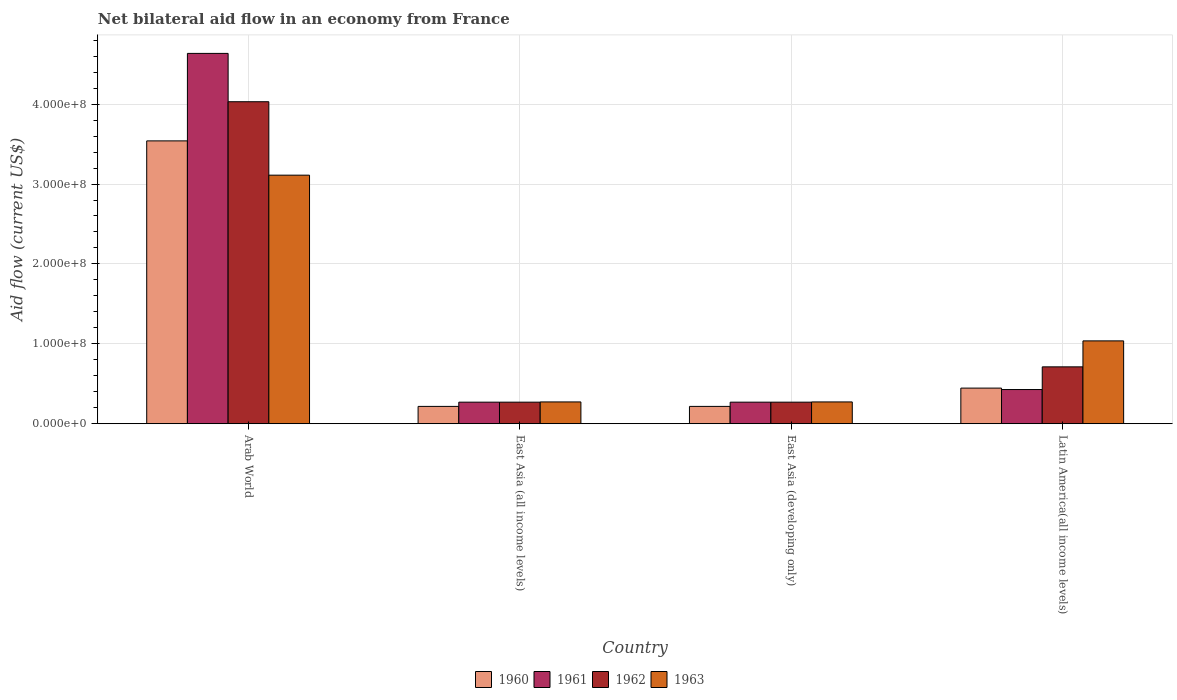How many different coloured bars are there?
Your response must be concise. 4. Are the number of bars per tick equal to the number of legend labels?
Ensure brevity in your answer.  Yes. How many bars are there on the 4th tick from the right?
Give a very brief answer. 4. What is the label of the 4th group of bars from the left?
Ensure brevity in your answer.  Latin America(all income levels). In how many cases, is the number of bars for a given country not equal to the number of legend labels?
Your response must be concise. 0. What is the net bilateral aid flow in 1962 in Latin America(all income levels)?
Your response must be concise. 7.12e+07. Across all countries, what is the maximum net bilateral aid flow in 1962?
Keep it short and to the point. 4.03e+08. Across all countries, what is the minimum net bilateral aid flow in 1963?
Keep it short and to the point. 2.73e+07. In which country was the net bilateral aid flow in 1961 maximum?
Give a very brief answer. Arab World. In which country was the net bilateral aid flow in 1961 minimum?
Give a very brief answer. East Asia (all income levels). What is the total net bilateral aid flow in 1963 in the graph?
Your response must be concise. 4.69e+08. What is the difference between the net bilateral aid flow in 1963 in Arab World and that in East Asia (all income levels)?
Your answer should be compact. 2.84e+08. What is the average net bilateral aid flow in 1961 per country?
Keep it short and to the point. 1.40e+08. What is the difference between the net bilateral aid flow of/in 1961 and net bilateral aid flow of/in 1960 in Latin America(all income levels)?
Make the answer very short. -1.80e+06. In how many countries, is the net bilateral aid flow in 1961 greater than 260000000 US$?
Offer a very short reply. 1. What is the ratio of the net bilateral aid flow in 1963 in East Asia (all income levels) to that in Latin America(all income levels)?
Your answer should be very brief. 0.26. Is the net bilateral aid flow in 1960 in Arab World less than that in East Asia (developing only)?
Keep it short and to the point. No. Is the difference between the net bilateral aid flow in 1961 in Arab World and East Asia (all income levels) greater than the difference between the net bilateral aid flow in 1960 in Arab World and East Asia (all income levels)?
Your answer should be compact. Yes. What is the difference between the highest and the second highest net bilateral aid flow in 1961?
Your answer should be very brief. 4.21e+08. What is the difference between the highest and the lowest net bilateral aid flow in 1963?
Give a very brief answer. 2.84e+08. What does the 4th bar from the left in East Asia (developing only) represents?
Offer a terse response. 1963. Is it the case that in every country, the sum of the net bilateral aid flow in 1962 and net bilateral aid flow in 1961 is greater than the net bilateral aid flow in 1963?
Offer a terse response. Yes. Are all the bars in the graph horizontal?
Give a very brief answer. No. What is the difference between two consecutive major ticks on the Y-axis?
Offer a terse response. 1.00e+08. Does the graph contain grids?
Your response must be concise. Yes. How are the legend labels stacked?
Keep it short and to the point. Horizontal. What is the title of the graph?
Your answer should be compact. Net bilateral aid flow in an economy from France. Does "2012" appear as one of the legend labels in the graph?
Provide a succinct answer. No. What is the label or title of the X-axis?
Ensure brevity in your answer.  Country. What is the Aid flow (current US$) in 1960 in Arab World?
Offer a very short reply. 3.54e+08. What is the Aid flow (current US$) of 1961 in Arab World?
Give a very brief answer. 4.64e+08. What is the Aid flow (current US$) in 1962 in Arab World?
Provide a succinct answer. 4.03e+08. What is the Aid flow (current US$) in 1963 in Arab World?
Give a very brief answer. 3.11e+08. What is the Aid flow (current US$) of 1960 in East Asia (all income levels)?
Offer a terse response. 2.17e+07. What is the Aid flow (current US$) in 1961 in East Asia (all income levels)?
Keep it short and to the point. 2.70e+07. What is the Aid flow (current US$) in 1962 in East Asia (all income levels)?
Provide a short and direct response. 2.70e+07. What is the Aid flow (current US$) in 1963 in East Asia (all income levels)?
Your answer should be very brief. 2.73e+07. What is the Aid flow (current US$) in 1960 in East Asia (developing only)?
Provide a succinct answer. 2.17e+07. What is the Aid flow (current US$) in 1961 in East Asia (developing only)?
Your response must be concise. 2.70e+07. What is the Aid flow (current US$) of 1962 in East Asia (developing only)?
Give a very brief answer. 2.70e+07. What is the Aid flow (current US$) of 1963 in East Asia (developing only)?
Make the answer very short. 2.73e+07. What is the Aid flow (current US$) in 1960 in Latin America(all income levels)?
Offer a very short reply. 4.46e+07. What is the Aid flow (current US$) of 1961 in Latin America(all income levels)?
Offer a terse response. 4.28e+07. What is the Aid flow (current US$) of 1962 in Latin America(all income levels)?
Ensure brevity in your answer.  7.12e+07. What is the Aid flow (current US$) of 1963 in Latin America(all income levels)?
Keep it short and to the point. 1.04e+08. Across all countries, what is the maximum Aid flow (current US$) of 1960?
Keep it short and to the point. 3.54e+08. Across all countries, what is the maximum Aid flow (current US$) of 1961?
Offer a terse response. 4.64e+08. Across all countries, what is the maximum Aid flow (current US$) in 1962?
Make the answer very short. 4.03e+08. Across all countries, what is the maximum Aid flow (current US$) of 1963?
Provide a short and direct response. 3.11e+08. Across all countries, what is the minimum Aid flow (current US$) in 1960?
Offer a terse response. 2.17e+07. Across all countries, what is the minimum Aid flow (current US$) of 1961?
Keep it short and to the point. 2.70e+07. Across all countries, what is the minimum Aid flow (current US$) of 1962?
Your answer should be very brief. 2.70e+07. Across all countries, what is the minimum Aid flow (current US$) of 1963?
Keep it short and to the point. 2.73e+07. What is the total Aid flow (current US$) in 1960 in the graph?
Provide a short and direct response. 4.42e+08. What is the total Aid flow (current US$) in 1961 in the graph?
Your response must be concise. 5.60e+08. What is the total Aid flow (current US$) in 1962 in the graph?
Your answer should be very brief. 5.28e+08. What is the total Aid flow (current US$) in 1963 in the graph?
Ensure brevity in your answer.  4.69e+08. What is the difference between the Aid flow (current US$) of 1960 in Arab World and that in East Asia (all income levels)?
Your answer should be compact. 3.32e+08. What is the difference between the Aid flow (current US$) in 1961 in Arab World and that in East Asia (all income levels)?
Keep it short and to the point. 4.36e+08. What is the difference between the Aid flow (current US$) in 1962 in Arab World and that in East Asia (all income levels)?
Offer a terse response. 3.76e+08. What is the difference between the Aid flow (current US$) of 1963 in Arab World and that in East Asia (all income levels)?
Make the answer very short. 2.84e+08. What is the difference between the Aid flow (current US$) in 1960 in Arab World and that in East Asia (developing only)?
Make the answer very short. 3.32e+08. What is the difference between the Aid flow (current US$) in 1961 in Arab World and that in East Asia (developing only)?
Your answer should be compact. 4.36e+08. What is the difference between the Aid flow (current US$) of 1962 in Arab World and that in East Asia (developing only)?
Offer a very short reply. 3.76e+08. What is the difference between the Aid flow (current US$) of 1963 in Arab World and that in East Asia (developing only)?
Offer a very short reply. 2.84e+08. What is the difference between the Aid flow (current US$) in 1960 in Arab World and that in Latin America(all income levels)?
Give a very brief answer. 3.09e+08. What is the difference between the Aid flow (current US$) of 1961 in Arab World and that in Latin America(all income levels)?
Give a very brief answer. 4.21e+08. What is the difference between the Aid flow (current US$) in 1962 in Arab World and that in Latin America(all income levels)?
Offer a very short reply. 3.32e+08. What is the difference between the Aid flow (current US$) in 1963 in Arab World and that in Latin America(all income levels)?
Your response must be concise. 2.07e+08. What is the difference between the Aid flow (current US$) of 1961 in East Asia (all income levels) and that in East Asia (developing only)?
Your answer should be compact. 0. What is the difference between the Aid flow (current US$) in 1963 in East Asia (all income levels) and that in East Asia (developing only)?
Provide a succinct answer. 0. What is the difference between the Aid flow (current US$) of 1960 in East Asia (all income levels) and that in Latin America(all income levels)?
Keep it short and to the point. -2.29e+07. What is the difference between the Aid flow (current US$) in 1961 in East Asia (all income levels) and that in Latin America(all income levels)?
Make the answer very short. -1.58e+07. What is the difference between the Aid flow (current US$) in 1962 in East Asia (all income levels) and that in Latin America(all income levels)?
Give a very brief answer. -4.42e+07. What is the difference between the Aid flow (current US$) in 1963 in East Asia (all income levels) and that in Latin America(all income levels)?
Make the answer very short. -7.64e+07. What is the difference between the Aid flow (current US$) in 1960 in East Asia (developing only) and that in Latin America(all income levels)?
Provide a short and direct response. -2.29e+07. What is the difference between the Aid flow (current US$) in 1961 in East Asia (developing only) and that in Latin America(all income levels)?
Provide a succinct answer. -1.58e+07. What is the difference between the Aid flow (current US$) of 1962 in East Asia (developing only) and that in Latin America(all income levels)?
Your answer should be very brief. -4.42e+07. What is the difference between the Aid flow (current US$) in 1963 in East Asia (developing only) and that in Latin America(all income levels)?
Provide a short and direct response. -7.64e+07. What is the difference between the Aid flow (current US$) of 1960 in Arab World and the Aid flow (current US$) of 1961 in East Asia (all income levels)?
Provide a succinct answer. 3.27e+08. What is the difference between the Aid flow (current US$) in 1960 in Arab World and the Aid flow (current US$) in 1962 in East Asia (all income levels)?
Make the answer very short. 3.27e+08. What is the difference between the Aid flow (current US$) in 1960 in Arab World and the Aid flow (current US$) in 1963 in East Asia (all income levels)?
Ensure brevity in your answer.  3.27e+08. What is the difference between the Aid flow (current US$) of 1961 in Arab World and the Aid flow (current US$) of 1962 in East Asia (all income levels)?
Give a very brief answer. 4.36e+08. What is the difference between the Aid flow (current US$) in 1961 in Arab World and the Aid flow (current US$) in 1963 in East Asia (all income levels)?
Your answer should be compact. 4.36e+08. What is the difference between the Aid flow (current US$) in 1962 in Arab World and the Aid flow (current US$) in 1963 in East Asia (all income levels)?
Your response must be concise. 3.76e+08. What is the difference between the Aid flow (current US$) of 1960 in Arab World and the Aid flow (current US$) of 1961 in East Asia (developing only)?
Ensure brevity in your answer.  3.27e+08. What is the difference between the Aid flow (current US$) of 1960 in Arab World and the Aid flow (current US$) of 1962 in East Asia (developing only)?
Your answer should be compact. 3.27e+08. What is the difference between the Aid flow (current US$) in 1960 in Arab World and the Aid flow (current US$) in 1963 in East Asia (developing only)?
Your answer should be very brief. 3.27e+08. What is the difference between the Aid flow (current US$) in 1961 in Arab World and the Aid flow (current US$) in 1962 in East Asia (developing only)?
Give a very brief answer. 4.36e+08. What is the difference between the Aid flow (current US$) of 1961 in Arab World and the Aid flow (current US$) of 1963 in East Asia (developing only)?
Provide a succinct answer. 4.36e+08. What is the difference between the Aid flow (current US$) of 1962 in Arab World and the Aid flow (current US$) of 1963 in East Asia (developing only)?
Your answer should be very brief. 3.76e+08. What is the difference between the Aid flow (current US$) in 1960 in Arab World and the Aid flow (current US$) in 1961 in Latin America(all income levels)?
Your answer should be compact. 3.11e+08. What is the difference between the Aid flow (current US$) in 1960 in Arab World and the Aid flow (current US$) in 1962 in Latin America(all income levels)?
Offer a very short reply. 2.83e+08. What is the difference between the Aid flow (current US$) in 1960 in Arab World and the Aid flow (current US$) in 1963 in Latin America(all income levels)?
Your response must be concise. 2.50e+08. What is the difference between the Aid flow (current US$) in 1961 in Arab World and the Aid flow (current US$) in 1962 in Latin America(all income levels)?
Your answer should be compact. 3.92e+08. What is the difference between the Aid flow (current US$) of 1961 in Arab World and the Aid flow (current US$) of 1963 in Latin America(all income levels)?
Keep it short and to the point. 3.60e+08. What is the difference between the Aid flow (current US$) in 1962 in Arab World and the Aid flow (current US$) in 1963 in Latin America(all income levels)?
Your response must be concise. 2.99e+08. What is the difference between the Aid flow (current US$) of 1960 in East Asia (all income levels) and the Aid flow (current US$) of 1961 in East Asia (developing only)?
Give a very brief answer. -5.30e+06. What is the difference between the Aid flow (current US$) of 1960 in East Asia (all income levels) and the Aid flow (current US$) of 1962 in East Asia (developing only)?
Ensure brevity in your answer.  -5.30e+06. What is the difference between the Aid flow (current US$) in 1960 in East Asia (all income levels) and the Aid flow (current US$) in 1963 in East Asia (developing only)?
Make the answer very short. -5.60e+06. What is the difference between the Aid flow (current US$) in 1960 in East Asia (all income levels) and the Aid flow (current US$) in 1961 in Latin America(all income levels)?
Ensure brevity in your answer.  -2.11e+07. What is the difference between the Aid flow (current US$) in 1960 in East Asia (all income levels) and the Aid flow (current US$) in 1962 in Latin America(all income levels)?
Give a very brief answer. -4.95e+07. What is the difference between the Aid flow (current US$) of 1960 in East Asia (all income levels) and the Aid flow (current US$) of 1963 in Latin America(all income levels)?
Keep it short and to the point. -8.20e+07. What is the difference between the Aid flow (current US$) in 1961 in East Asia (all income levels) and the Aid flow (current US$) in 1962 in Latin America(all income levels)?
Make the answer very short. -4.42e+07. What is the difference between the Aid flow (current US$) in 1961 in East Asia (all income levels) and the Aid flow (current US$) in 1963 in Latin America(all income levels)?
Ensure brevity in your answer.  -7.67e+07. What is the difference between the Aid flow (current US$) in 1962 in East Asia (all income levels) and the Aid flow (current US$) in 1963 in Latin America(all income levels)?
Ensure brevity in your answer.  -7.67e+07. What is the difference between the Aid flow (current US$) of 1960 in East Asia (developing only) and the Aid flow (current US$) of 1961 in Latin America(all income levels)?
Keep it short and to the point. -2.11e+07. What is the difference between the Aid flow (current US$) in 1960 in East Asia (developing only) and the Aid flow (current US$) in 1962 in Latin America(all income levels)?
Ensure brevity in your answer.  -4.95e+07. What is the difference between the Aid flow (current US$) in 1960 in East Asia (developing only) and the Aid flow (current US$) in 1963 in Latin America(all income levels)?
Offer a terse response. -8.20e+07. What is the difference between the Aid flow (current US$) in 1961 in East Asia (developing only) and the Aid flow (current US$) in 1962 in Latin America(all income levels)?
Provide a succinct answer. -4.42e+07. What is the difference between the Aid flow (current US$) of 1961 in East Asia (developing only) and the Aid flow (current US$) of 1963 in Latin America(all income levels)?
Ensure brevity in your answer.  -7.67e+07. What is the difference between the Aid flow (current US$) of 1962 in East Asia (developing only) and the Aid flow (current US$) of 1963 in Latin America(all income levels)?
Ensure brevity in your answer.  -7.67e+07. What is the average Aid flow (current US$) in 1960 per country?
Your answer should be compact. 1.10e+08. What is the average Aid flow (current US$) in 1961 per country?
Keep it short and to the point. 1.40e+08. What is the average Aid flow (current US$) of 1962 per country?
Make the answer very short. 1.32e+08. What is the average Aid flow (current US$) of 1963 per country?
Provide a succinct answer. 1.17e+08. What is the difference between the Aid flow (current US$) of 1960 and Aid flow (current US$) of 1961 in Arab World?
Your response must be concise. -1.10e+08. What is the difference between the Aid flow (current US$) of 1960 and Aid flow (current US$) of 1962 in Arab World?
Your response must be concise. -4.90e+07. What is the difference between the Aid flow (current US$) in 1960 and Aid flow (current US$) in 1963 in Arab World?
Give a very brief answer. 4.29e+07. What is the difference between the Aid flow (current US$) in 1961 and Aid flow (current US$) in 1962 in Arab World?
Provide a short and direct response. 6.05e+07. What is the difference between the Aid flow (current US$) of 1961 and Aid flow (current US$) of 1963 in Arab World?
Provide a short and direct response. 1.52e+08. What is the difference between the Aid flow (current US$) of 1962 and Aid flow (current US$) of 1963 in Arab World?
Your response must be concise. 9.19e+07. What is the difference between the Aid flow (current US$) in 1960 and Aid flow (current US$) in 1961 in East Asia (all income levels)?
Provide a succinct answer. -5.30e+06. What is the difference between the Aid flow (current US$) of 1960 and Aid flow (current US$) of 1962 in East Asia (all income levels)?
Keep it short and to the point. -5.30e+06. What is the difference between the Aid flow (current US$) in 1960 and Aid flow (current US$) in 1963 in East Asia (all income levels)?
Provide a short and direct response. -5.60e+06. What is the difference between the Aid flow (current US$) of 1960 and Aid flow (current US$) of 1961 in East Asia (developing only)?
Provide a short and direct response. -5.30e+06. What is the difference between the Aid flow (current US$) of 1960 and Aid flow (current US$) of 1962 in East Asia (developing only)?
Your answer should be compact. -5.30e+06. What is the difference between the Aid flow (current US$) of 1960 and Aid flow (current US$) of 1963 in East Asia (developing only)?
Your response must be concise. -5.60e+06. What is the difference between the Aid flow (current US$) in 1960 and Aid flow (current US$) in 1961 in Latin America(all income levels)?
Your response must be concise. 1.80e+06. What is the difference between the Aid flow (current US$) in 1960 and Aid flow (current US$) in 1962 in Latin America(all income levels)?
Your response must be concise. -2.66e+07. What is the difference between the Aid flow (current US$) in 1960 and Aid flow (current US$) in 1963 in Latin America(all income levels)?
Your answer should be very brief. -5.91e+07. What is the difference between the Aid flow (current US$) of 1961 and Aid flow (current US$) of 1962 in Latin America(all income levels)?
Give a very brief answer. -2.84e+07. What is the difference between the Aid flow (current US$) in 1961 and Aid flow (current US$) in 1963 in Latin America(all income levels)?
Provide a succinct answer. -6.09e+07. What is the difference between the Aid flow (current US$) of 1962 and Aid flow (current US$) of 1963 in Latin America(all income levels)?
Your response must be concise. -3.25e+07. What is the ratio of the Aid flow (current US$) in 1960 in Arab World to that in East Asia (all income levels)?
Ensure brevity in your answer.  16.31. What is the ratio of the Aid flow (current US$) of 1961 in Arab World to that in East Asia (all income levels)?
Provide a succinct answer. 17.17. What is the ratio of the Aid flow (current US$) in 1962 in Arab World to that in East Asia (all income levels)?
Your response must be concise. 14.93. What is the ratio of the Aid flow (current US$) in 1963 in Arab World to that in East Asia (all income levels)?
Give a very brief answer. 11.4. What is the ratio of the Aid flow (current US$) of 1960 in Arab World to that in East Asia (developing only)?
Your answer should be very brief. 16.31. What is the ratio of the Aid flow (current US$) of 1961 in Arab World to that in East Asia (developing only)?
Ensure brevity in your answer.  17.17. What is the ratio of the Aid flow (current US$) in 1962 in Arab World to that in East Asia (developing only)?
Make the answer very short. 14.93. What is the ratio of the Aid flow (current US$) of 1963 in Arab World to that in East Asia (developing only)?
Ensure brevity in your answer.  11.4. What is the ratio of the Aid flow (current US$) of 1960 in Arab World to that in Latin America(all income levels)?
Ensure brevity in your answer.  7.94. What is the ratio of the Aid flow (current US$) in 1961 in Arab World to that in Latin America(all income levels)?
Provide a short and direct response. 10.83. What is the ratio of the Aid flow (current US$) in 1962 in Arab World to that in Latin America(all income levels)?
Provide a short and direct response. 5.66. What is the ratio of the Aid flow (current US$) of 1963 in Arab World to that in Latin America(all income levels)?
Offer a terse response. 3. What is the ratio of the Aid flow (current US$) of 1961 in East Asia (all income levels) to that in East Asia (developing only)?
Ensure brevity in your answer.  1. What is the ratio of the Aid flow (current US$) in 1962 in East Asia (all income levels) to that in East Asia (developing only)?
Ensure brevity in your answer.  1. What is the ratio of the Aid flow (current US$) of 1960 in East Asia (all income levels) to that in Latin America(all income levels)?
Keep it short and to the point. 0.49. What is the ratio of the Aid flow (current US$) in 1961 in East Asia (all income levels) to that in Latin America(all income levels)?
Provide a short and direct response. 0.63. What is the ratio of the Aid flow (current US$) of 1962 in East Asia (all income levels) to that in Latin America(all income levels)?
Your answer should be very brief. 0.38. What is the ratio of the Aid flow (current US$) of 1963 in East Asia (all income levels) to that in Latin America(all income levels)?
Your answer should be compact. 0.26. What is the ratio of the Aid flow (current US$) in 1960 in East Asia (developing only) to that in Latin America(all income levels)?
Keep it short and to the point. 0.49. What is the ratio of the Aid flow (current US$) in 1961 in East Asia (developing only) to that in Latin America(all income levels)?
Give a very brief answer. 0.63. What is the ratio of the Aid flow (current US$) of 1962 in East Asia (developing only) to that in Latin America(all income levels)?
Your answer should be compact. 0.38. What is the ratio of the Aid flow (current US$) in 1963 in East Asia (developing only) to that in Latin America(all income levels)?
Ensure brevity in your answer.  0.26. What is the difference between the highest and the second highest Aid flow (current US$) of 1960?
Give a very brief answer. 3.09e+08. What is the difference between the highest and the second highest Aid flow (current US$) in 1961?
Provide a short and direct response. 4.21e+08. What is the difference between the highest and the second highest Aid flow (current US$) in 1962?
Make the answer very short. 3.32e+08. What is the difference between the highest and the second highest Aid flow (current US$) of 1963?
Your answer should be compact. 2.07e+08. What is the difference between the highest and the lowest Aid flow (current US$) in 1960?
Make the answer very short. 3.32e+08. What is the difference between the highest and the lowest Aid flow (current US$) in 1961?
Make the answer very short. 4.36e+08. What is the difference between the highest and the lowest Aid flow (current US$) of 1962?
Your answer should be compact. 3.76e+08. What is the difference between the highest and the lowest Aid flow (current US$) in 1963?
Give a very brief answer. 2.84e+08. 